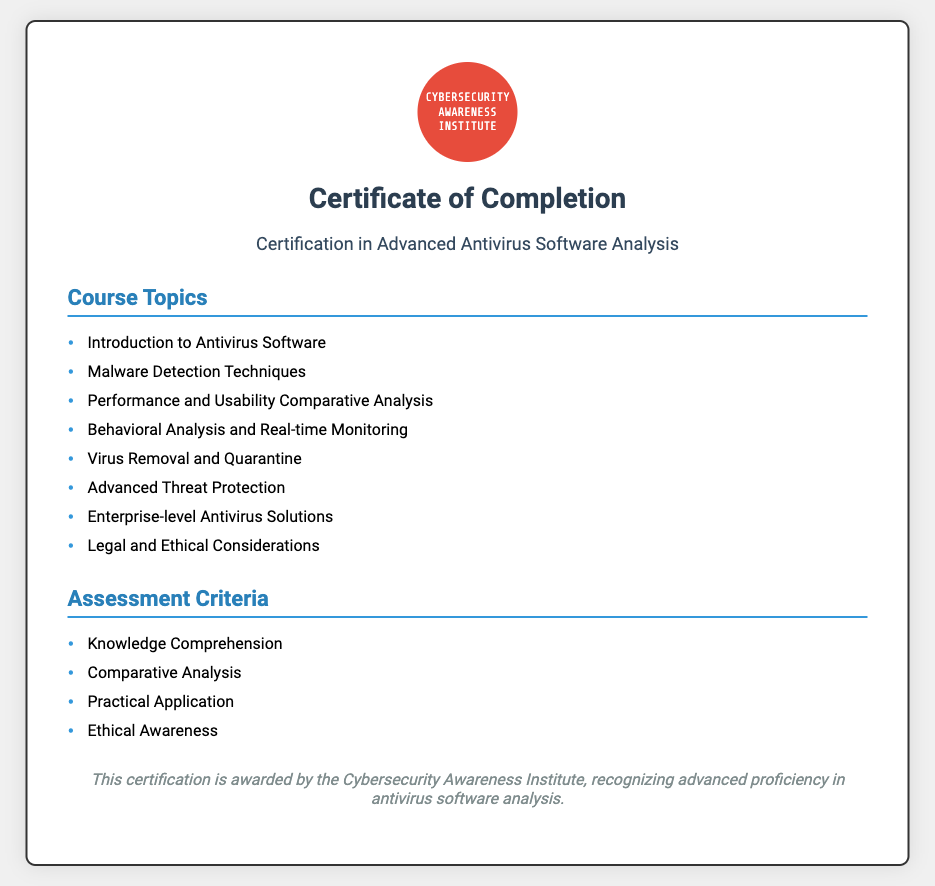What is the name of the issuing institute? The name of the issuing institute is specified in the document as the Cybersecurity Awareness Institute.
Answer: Cybersecurity Awareness Institute What is the title of the certificate? The title of the certificate is mentioned prominently at the top of the document.
Answer: Certificate of Completion How many course topics are listed? The number of course topics is determined by counting the items in the "Course Topics" list.
Answer: Eight What is one method covered for malware detection? The document lists various methods under the "Course Topics" section, one of which is explicitly mentioned.
Answer: Malware Detection Techniques What criteria are used for assessment? The assessment criteria is a list that can be retrieved from the "Assessment Criteria" section of the document.
Answer: Knowledge Comprehension Which aspect of antivirus software is related to ethics? Ethical considerations are noted as part of the course content and appear in the list under "Course Topics" or "Assessment Criteria".
Answer: Legal and Ethical Considerations What is one key feature discussed for enterprise-level antivirus solutions? The document mentions several aspects but does not specify details, suggesting one key feature listed is significant.
Answer: Enterprise-level Antivirus Solutions How is the certificate described in terms of recognition? The document states how the certificate is awarded and its significance in the footer section.
Answer: Recognizing advanced proficiency 